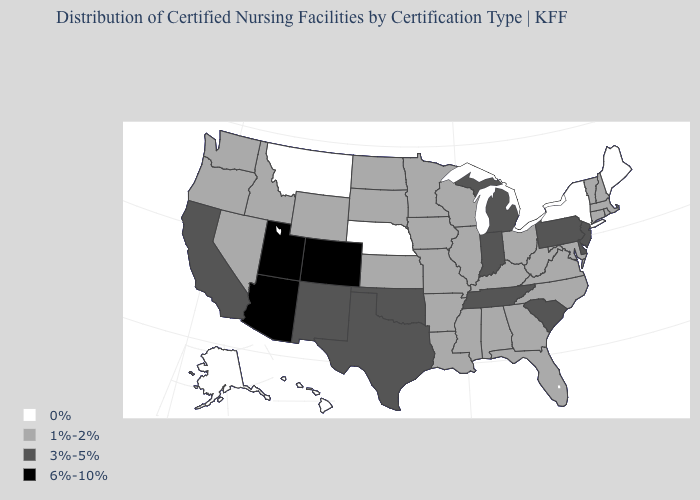Name the states that have a value in the range 0%?
Write a very short answer. Alaska, Hawaii, Maine, Montana, Nebraska, New York. Which states have the highest value in the USA?
Keep it brief. Arizona, Colorado, Utah. Which states have the lowest value in the USA?
Write a very short answer. Alaska, Hawaii, Maine, Montana, Nebraska, New York. Does Colorado have the highest value in the USA?
Be succinct. Yes. Name the states that have a value in the range 6%-10%?
Be succinct. Arizona, Colorado, Utah. Name the states that have a value in the range 6%-10%?
Be succinct. Arizona, Colorado, Utah. Does Iowa have the lowest value in the USA?
Concise answer only. No. Does the map have missing data?
Short answer required. No. Which states hav the highest value in the Northeast?
Concise answer only. New Jersey, Pennsylvania. What is the value of Alaska?
Give a very brief answer. 0%. Does Massachusetts have the lowest value in the Northeast?
Answer briefly. No. What is the lowest value in states that border Idaho?
Quick response, please. 0%. Does Minnesota have the same value as Iowa?
Short answer required. Yes. 